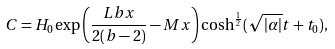Convert formula to latex. <formula><loc_0><loc_0><loc_500><loc_500>C = H _ { 0 } \exp { \left ( \frac { L b x } { 2 ( b - 2 ) } - M x \right ) } \cosh ^ { \frac { 1 } { 2 } } ( \sqrt { | \alpha | } t + t _ { 0 } ) ,</formula> 